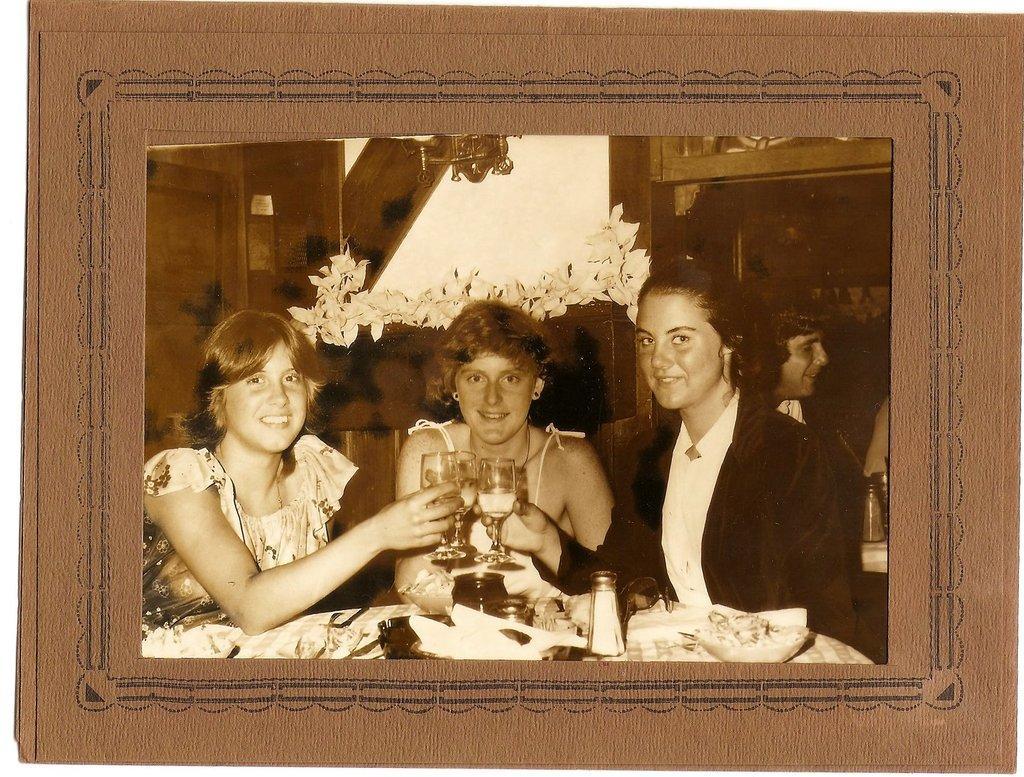In one or two sentences, can you explain what this image depicts? In this picture I can see the photo which is placed on the wall. In that photo there are three women who are holding the wine glass and sitting on the chair. Behind them I can see another person who is sitting near to the table. On the table I can see the glasses. 